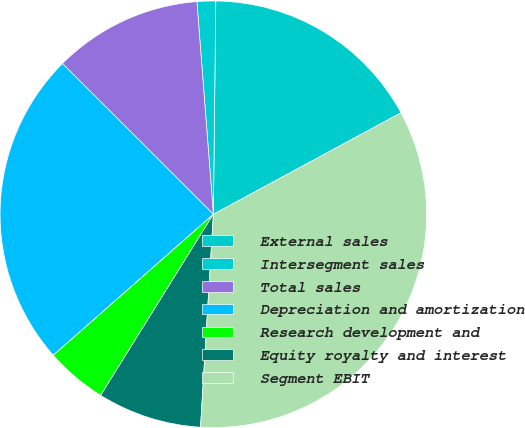Convert chart. <chart><loc_0><loc_0><loc_500><loc_500><pie_chart><fcel>External sales<fcel>Intersegment sales<fcel>Total sales<fcel>Depreciation and amortization<fcel>Research development and<fcel>Equity royalty and interest<fcel>Segment EBIT<nl><fcel>16.93%<fcel>1.41%<fcel>11.28%<fcel>23.98%<fcel>4.65%<fcel>7.9%<fcel>33.85%<nl></chart> 